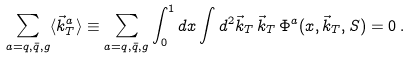<formula> <loc_0><loc_0><loc_500><loc_500>\sum _ { a = q , \bar { q } , g } \langle \vec { k } _ { T } ^ { a } \rangle \equiv \sum _ { a = q , \bar { q } , g } \int _ { 0 } ^ { 1 } d x \int d ^ { 2 } \vec { k } _ { T } \, \vec { k } _ { T } \, \Phi ^ { a } ( x , \vec { k } _ { T } , S ) = 0 \, .</formula> 